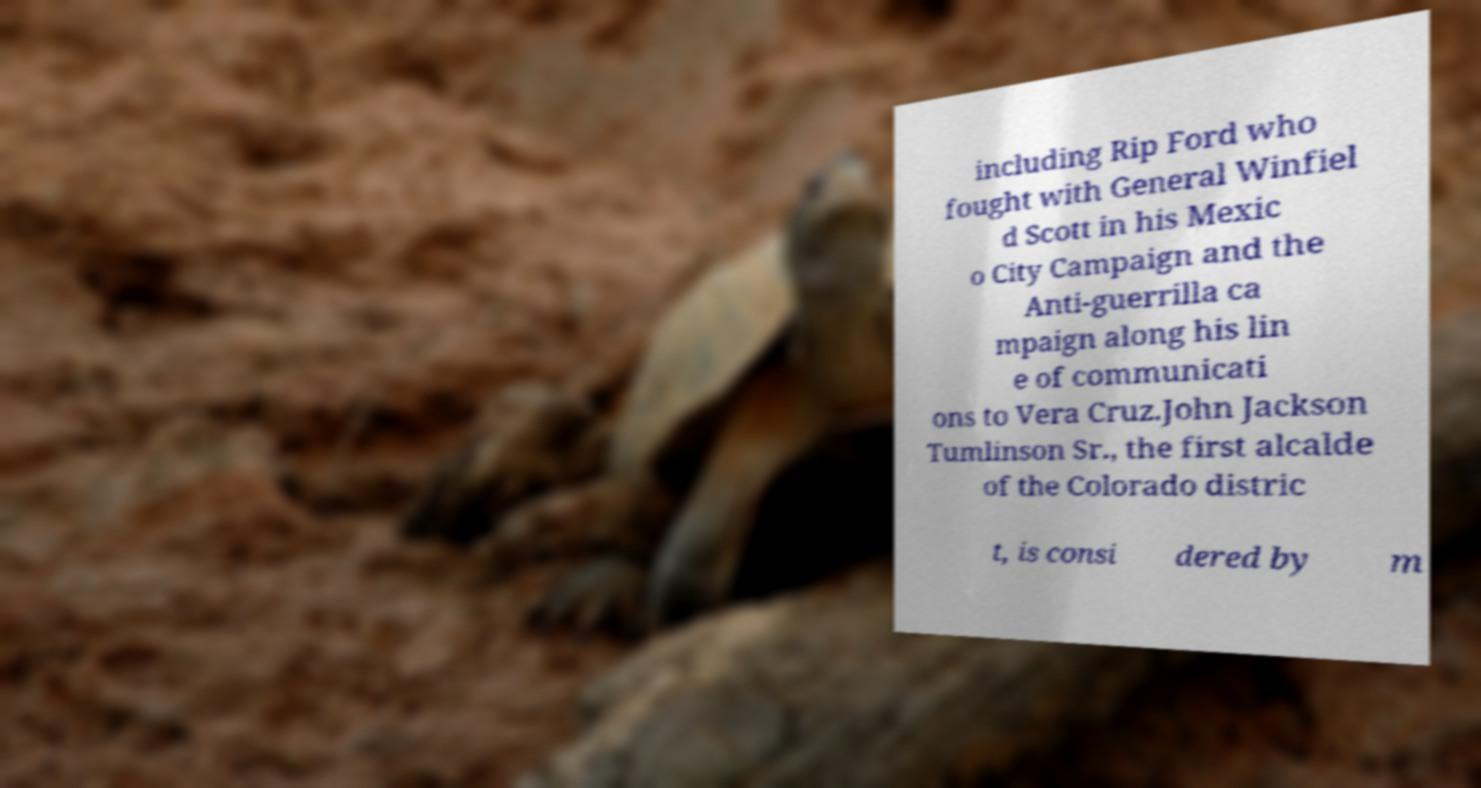I need the written content from this picture converted into text. Can you do that? including Rip Ford who fought with General Winfiel d Scott in his Mexic o City Campaign and the Anti-guerrilla ca mpaign along his lin e of communicati ons to Vera Cruz.John Jackson Tumlinson Sr., the first alcalde of the Colorado distric t, is consi dered by m 